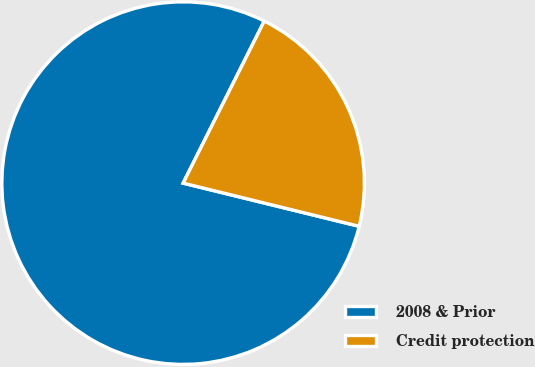Convert chart to OTSL. <chart><loc_0><loc_0><loc_500><loc_500><pie_chart><fcel>2008 & Prior<fcel>Credit protection<nl><fcel>78.56%<fcel>21.44%<nl></chart> 